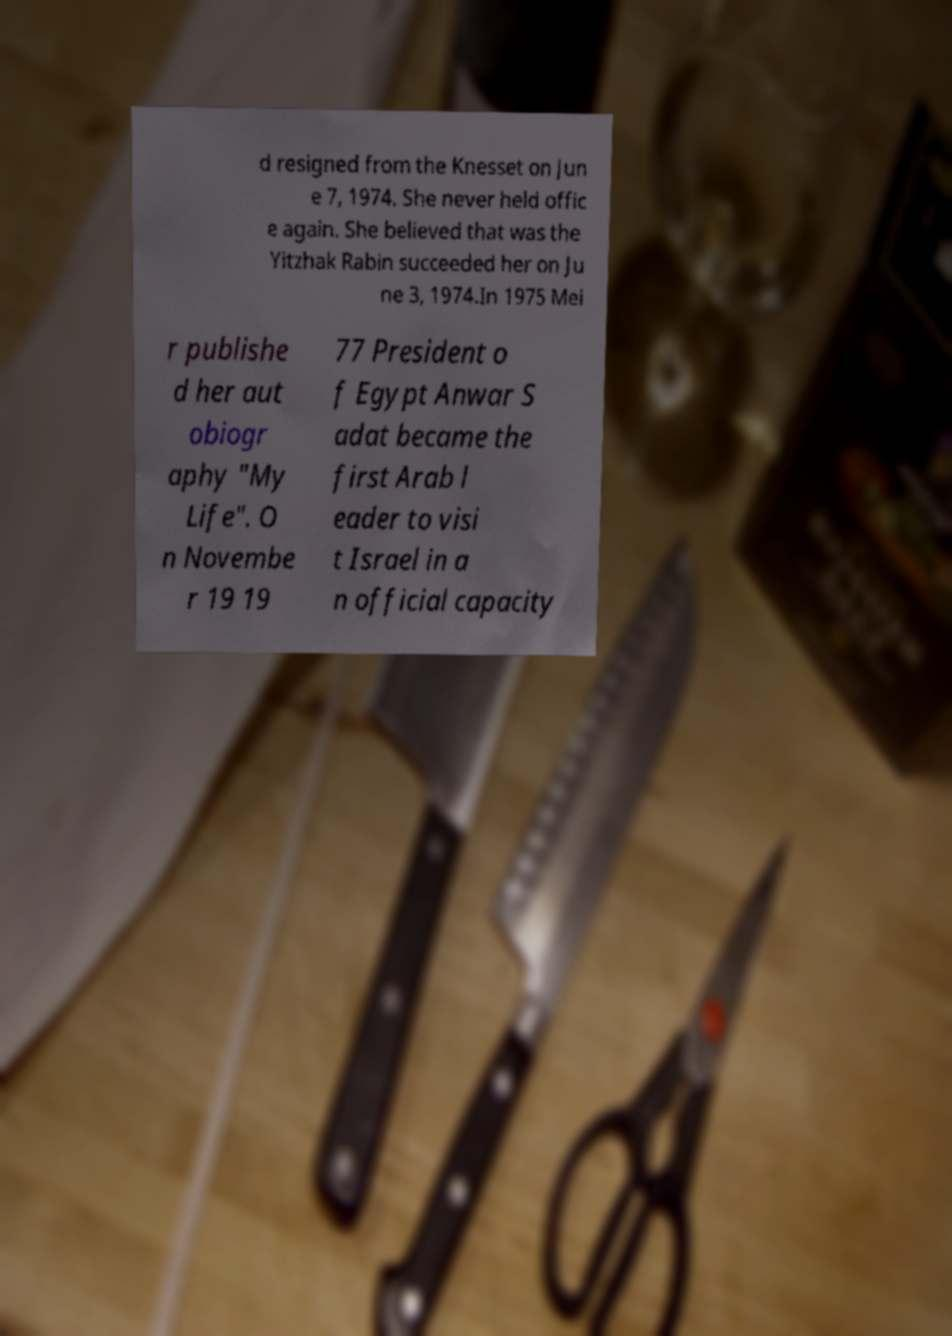Please read and relay the text visible in this image. What does it say? d resigned from the Knesset on Jun e 7, 1974. She never held offic e again. She believed that was the Yitzhak Rabin succeeded her on Ju ne 3, 1974.In 1975 Mei r publishe d her aut obiogr aphy "My Life". O n Novembe r 19 19 77 President o f Egypt Anwar S adat became the first Arab l eader to visi t Israel in a n official capacity 